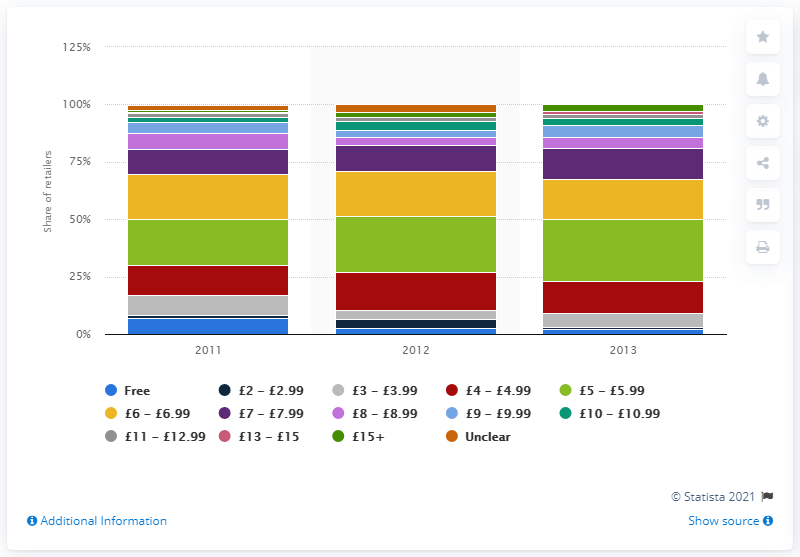Specify some key components in this picture. In 2013, approximately 2.3% of online retailers offered free next-day delivery services. 